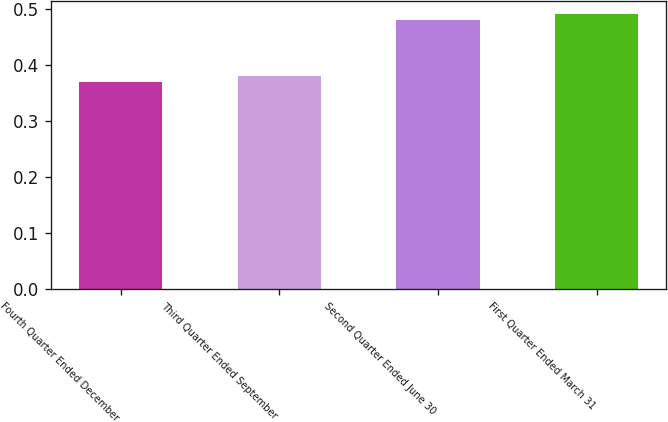Convert chart. <chart><loc_0><loc_0><loc_500><loc_500><bar_chart><fcel>Fourth Quarter Ended December<fcel>Third Quarter Ended September<fcel>Second Quarter Ended June 30<fcel>First Quarter Ended March 31<nl><fcel>0.37<fcel>0.38<fcel>0.48<fcel>0.49<nl></chart> 